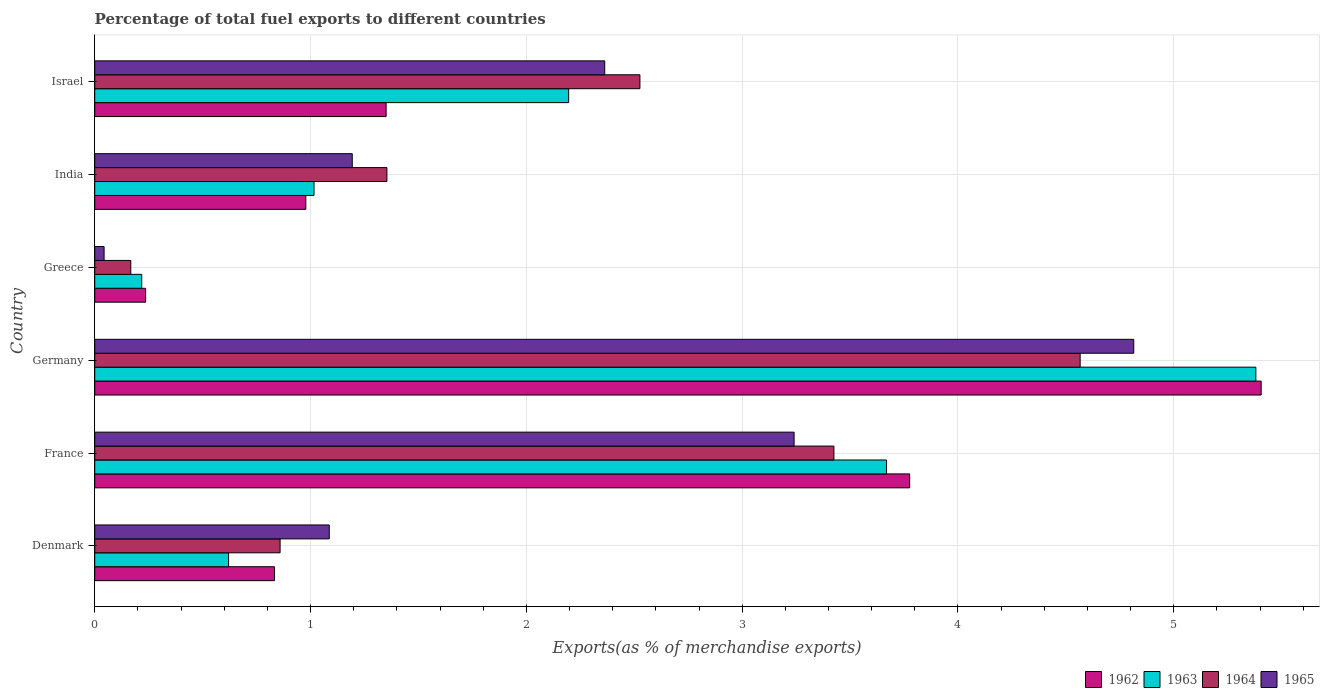How many different coloured bars are there?
Your answer should be very brief. 4. Are the number of bars per tick equal to the number of legend labels?
Offer a terse response. Yes. How many bars are there on the 4th tick from the top?
Your answer should be compact. 4. How many bars are there on the 1st tick from the bottom?
Offer a terse response. 4. What is the label of the 1st group of bars from the top?
Offer a terse response. Israel. What is the percentage of exports to different countries in 1962 in Israel?
Your answer should be compact. 1.35. Across all countries, what is the maximum percentage of exports to different countries in 1965?
Offer a very short reply. 4.81. Across all countries, what is the minimum percentage of exports to different countries in 1964?
Offer a very short reply. 0.17. What is the total percentage of exports to different countries in 1962 in the graph?
Your answer should be compact. 12.58. What is the difference between the percentage of exports to different countries in 1964 in India and that in Israel?
Keep it short and to the point. -1.17. What is the difference between the percentage of exports to different countries in 1963 in Greece and the percentage of exports to different countries in 1965 in Israel?
Give a very brief answer. -2.15. What is the average percentage of exports to different countries in 1963 per country?
Provide a short and direct response. 2.18. What is the difference between the percentage of exports to different countries in 1965 and percentage of exports to different countries in 1962 in Greece?
Ensure brevity in your answer.  -0.19. What is the ratio of the percentage of exports to different countries in 1962 in Denmark to that in France?
Give a very brief answer. 0.22. Is the percentage of exports to different countries in 1963 in France less than that in Israel?
Keep it short and to the point. No. Is the difference between the percentage of exports to different countries in 1965 in Denmark and India greater than the difference between the percentage of exports to different countries in 1962 in Denmark and India?
Your response must be concise. Yes. What is the difference between the highest and the second highest percentage of exports to different countries in 1964?
Your response must be concise. 1.14. What is the difference between the highest and the lowest percentage of exports to different countries in 1964?
Provide a succinct answer. 4.4. Is the sum of the percentage of exports to different countries in 1965 in Denmark and Germany greater than the maximum percentage of exports to different countries in 1963 across all countries?
Your answer should be very brief. Yes. What does the 3rd bar from the bottom in Israel represents?
Offer a terse response. 1964. Are all the bars in the graph horizontal?
Offer a terse response. Yes. How many countries are there in the graph?
Your answer should be compact. 6. Does the graph contain grids?
Ensure brevity in your answer.  Yes. How many legend labels are there?
Offer a terse response. 4. What is the title of the graph?
Keep it short and to the point. Percentage of total fuel exports to different countries. Does "2003" appear as one of the legend labels in the graph?
Offer a very short reply. No. What is the label or title of the X-axis?
Offer a terse response. Exports(as % of merchandise exports). What is the Exports(as % of merchandise exports) in 1962 in Denmark?
Provide a succinct answer. 0.83. What is the Exports(as % of merchandise exports) of 1963 in Denmark?
Offer a very short reply. 0.62. What is the Exports(as % of merchandise exports) in 1964 in Denmark?
Keep it short and to the point. 0.86. What is the Exports(as % of merchandise exports) of 1965 in Denmark?
Make the answer very short. 1.09. What is the Exports(as % of merchandise exports) of 1962 in France?
Provide a succinct answer. 3.78. What is the Exports(as % of merchandise exports) in 1963 in France?
Give a very brief answer. 3.67. What is the Exports(as % of merchandise exports) in 1964 in France?
Your response must be concise. 3.43. What is the Exports(as % of merchandise exports) in 1965 in France?
Your answer should be very brief. 3.24. What is the Exports(as % of merchandise exports) of 1962 in Germany?
Give a very brief answer. 5.4. What is the Exports(as % of merchandise exports) in 1963 in Germany?
Your answer should be compact. 5.38. What is the Exports(as % of merchandise exports) of 1964 in Germany?
Keep it short and to the point. 4.57. What is the Exports(as % of merchandise exports) in 1965 in Germany?
Provide a short and direct response. 4.81. What is the Exports(as % of merchandise exports) of 1962 in Greece?
Provide a short and direct response. 0.24. What is the Exports(as % of merchandise exports) in 1963 in Greece?
Your response must be concise. 0.22. What is the Exports(as % of merchandise exports) of 1964 in Greece?
Your response must be concise. 0.17. What is the Exports(as % of merchandise exports) of 1965 in Greece?
Your response must be concise. 0.04. What is the Exports(as % of merchandise exports) in 1962 in India?
Make the answer very short. 0.98. What is the Exports(as % of merchandise exports) in 1963 in India?
Give a very brief answer. 1.02. What is the Exports(as % of merchandise exports) of 1964 in India?
Ensure brevity in your answer.  1.35. What is the Exports(as % of merchandise exports) in 1965 in India?
Offer a very short reply. 1.19. What is the Exports(as % of merchandise exports) of 1962 in Israel?
Your answer should be compact. 1.35. What is the Exports(as % of merchandise exports) in 1963 in Israel?
Provide a succinct answer. 2.2. What is the Exports(as % of merchandise exports) of 1964 in Israel?
Your answer should be compact. 2.53. What is the Exports(as % of merchandise exports) of 1965 in Israel?
Make the answer very short. 2.36. Across all countries, what is the maximum Exports(as % of merchandise exports) in 1962?
Offer a terse response. 5.4. Across all countries, what is the maximum Exports(as % of merchandise exports) in 1963?
Your answer should be very brief. 5.38. Across all countries, what is the maximum Exports(as % of merchandise exports) of 1964?
Provide a short and direct response. 4.57. Across all countries, what is the maximum Exports(as % of merchandise exports) of 1965?
Offer a terse response. 4.81. Across all countries, what is the minimum Exports(as % of merchandise exports) of 1962?
Your answer should be compact. 0.24. Across all countries, what is the minimum Exports(as % of merchandise exports) of 1963?
Provide a succinct answer. 0.22. Across all countries, what is the minimum Exports(as % of merchandise exports) in 1964?
Give a very brief answer. 0.17. Across all countries, what is the minimum Exports(as % of merchandise exports) of 1965?
Provide a short and direct response. 0.04. What is the total Exports(as % of merchandise exports) of 1962 in the graph?
Provide a short and direct response. 12.58. What is the total Exports(as % of merchandise exports) in 1963 in the graph?
Ensure brevity in your answer.  13.1. What is the total Exports(as % of merchandise exports) in 1964 in the graph?
Offer a very short reply. 12.9. What is the total Exports(as % of merchandise exports) of 1965 in the graph?
Provide a succinct answer. 12.74. What is the difference between the Exports(as % of merchandise exports) in 1962 in Denmark and that in France?
Ensure brevity in your answer.  -2.94. What is the difference between the Exports(as % of merchandise exports) in 1963 in Denmark and that in France?
Ensure brevity in your answer.  -3.05. What is the difference between the Exports(as % of merchandise exports) of 1964 in Denmark and that in France?
Your answer should be very brief. -2.57. What is the difference between the Exports(as % of merchandise exports) of 1965 in Denmark and that in France?
Keep it short and to the point. -2.15. What is the difference between the Exports(as % of merchandise exports) of 1962 in Denmark and that in Germany?
Make the answer very short. -4.57. What is the difference between the Exports(as % of merchandise exports) in 1963 in Denmark and that in Germany?
Ensure brevity in your answer.  -4.76. What is the difference between the Exports(as % of merchandise exports) of 1964 in Denmark and that in Germany?
Keep it short and to the point. -3.71. What is the difference between the Exports(as % of merchandise exports) in 1965 in Denmark and that in Germany?
Make the answer very short. -3.73. What is the difference between the Exports(as % of merchandise exports) of 1962 in Denmark and that in Greece?
Ensure brevity in your answer.  0.6. What is the difference between the Exports(as % of merchandise exports) of 1963 in Denmark and that in Greece?
Provide a succinct answer. 0.4. What is the difference between the Exports(as % of merchandise exports) of 1964 in Denmark and that in Greece?
Your response must be concise. 0.69. What is the difference between the Exports(as % of merchandise exports) of 1965 in Denmark and that in Greece?
Make the answer very short. 1.04. What is the difference between the Exports(as % of merchandise exports) of 1962 in Denmark and that in India?
Offer a very short reply. -0.14. What is the difference between the Exports(as % of merchandise exports) in 1963 in Denmark and that in India?
Offer a terse response. -0.4. What is the difference between the Exports(as % of merchandise exports) in 1964 in Denmark and that in India?
Make the answer very short. -0.49. What is the difference between the Exports(as % of merchandise exports) of 1965 in Denmark and that in India?
Provide a short and direct response. -0.11. What is the difference between the Exports(as % of merchandise exports) in 1962 in Denmark and that in Israel?
Your answer should be compact. -0.52. What is the difference between the Exports(as % of merchandise exports) of 1963 in Denmark and that in Israel?
Offer a very short reply. -1.58. What is the difference between the Exports(as % of merchandise exports) of 1964 in Denmark and that in Israel?
Offer a very short reply. -1.67. What is the difference between the Exports(as % of merchandise exports) in 1965 in Denmark and that in Israel?
Offer a very short reply. -1.28. What is the difference between the Exports(as % of merchandise exports) of 1962 in France and that in Germany?
Your answer should be compact. -1.63. What is the difference between the Exports(as % of merchandise exports) in 1963 in France and that in Germany?
Provide a short and direct response. -1.71. What is the difference between the Exports(as % of merchandise exports) of 1964 in France and that in Germany?
Your answer should be very brief. -1.14. What is the difference between the Exports(as % of merchandise exports) in 1965 in France and that in Germany?
Your answer should be very brief. -1.57. What is the difference between the Exports(as % of merchandise exports) of 1962 in France and that in Greece?
Ensure brevity in your answer.  3.54. What is the difference between the Exports(as % of merchandise exports) in 1963 in France and that in Greece?
Keep it short and to the point. 3.45. What is the difference between the Exports(as % of merchandise exports) of 1964 in France and that in Greece?
Ensure brevity in your answer.  3.26. What is the difference between the Exports(as % of merchandise exports) of 1965 in France and that in Greece?
Your answer should be compact. 3.2. What is the difference between the Exports(as % of merchandise exports) in 1962 in France and that in India?
Offer a very short reply. 2.8. What is the difference between the Exports(as % of merchandise exports) of 1963 in France and that in India?
Provide a succinct answer. 2.65. What is the difference between the Exports(as % of merchandise exports) in 1964 in France and that in India?
Your answer should be very brief. 2.07. What is the difference between the Exports(as % of merchandise exports) in 1965 in France and that in India?
Offer a very short reply. 2.05. What is the difference between the Exports(as % of merchandise exports) of 1962 in France and that in Israel?
Provide a short and direct response. 2.43. What is the difference between the Exports(as % of merchandise exports) of 1963 in France and that in Israel?
Your answer should be compact. 1.47. What is the difference between the Exports(as % of merchandise exports) of 1964 in France and that in Israel?
Provide a succinct answer. 0.9. What is the difference between the Exports(as % of merchandise exports) in 1965 in France and that in Israel?
Ensure brevity in your answer.  0.88. What is the difference between the Exports(as % of merchandise exports) of 1962 in Germany and that in Greece?
Provide a succinct answer. 5.17. What is the difference between the Exports(as % of merchandise exports) of 1963 in Germany and that in Greece?
Provide a succinct answer. 5.16. What is the difference between the Exports(as % of merchandise exports) of 1964 in Germany and that in Greece?
Your response must be concise. 4.4. What is the difference between the Exports(as % of merchandise exports) of 1965 in Germany and that in Greece?
Offer a very short reply. 4.77. What is the difference between the Exports(as % of merchandise exports) of 1962 in Germany and that in India?
Ensure brevity in your answer.  4.43. What is the difference between the Exports(as % of merchandise exports) of 1963 in Germany and that in India?
Provide a succinct answer. 4.36. What is the difference between the Exports(as % of merchandise exports) in 1964 in Germany and that in India?
Offer a very short reply. 3.21. What is the difference between the Exports(as % of merchandise exports) of 1965 in Germany and that in India?
Your answer should be compact. 3.62. What is the difference between the Exports(as % of merchandise exports) in 1962 in Germany and that in Israel?
Provide a short and direct response. 4.05. What is the difference between the Exports(as % of merchandise exports) of 1963 in Germany and that in Israel?
Your answer should be very brief. 3.18. What is the difference between the Exports(as % of merchandise exports) in 1964 in Germany and that in Israel?
Offer a terse response. 2.04. What is the difference between the Exports(as % of merchandise exports) in 1965 in Germany and that in Israel?
Make the answer very short. 2.45. What is the difference between the Exports(as % of merchandise exports) in 1962 in Greece and that in India?
Offer a very short reply. -0.74. What is the difference between the Exports(as % of merchandise exports) in 1963 in Greece and that in India?
Ensure brevity in your answer.  -0.8. What is the difference between the Exports(as % of merchandise exports) in 1964 in Greece and that in India?
Offer a terse response. -1.19. What is the difference between the Exports(as % of merchandise exports) in 1965 in Greece and that in India?
Provide a succinct answer. -1.15. What is the difference between the Exports(as % of merchandise exports) of 1962 in Greece and that in Israel?
Give a very brief answer. -1.11. What is the difference between the Exports(as % of merchandise exports) of 1963 in Greece and that in Israel?
Your answer should be very brief. -1.98. What is the difference between the Exports(as % of merchandise exports) of 1964 in Greece and that in Israel?
Ensure brevity in your answer.  -2.36. What is the difference between the Exports(as % of merchandise exports) in 1965 in Greece and that in Israel?
Keep it short and to the point. -2.32. What is the difference between the Exports(as % of merchandise exports) of 1962 in India and that in Israel?
Your answer should be compact. -0.37. What is the difference between the Exports(as % of merchandise exports) in 1963 in India and that in Israel?
Your answer should be very brief. -1.18. What is the difference between the Exports(as % of merchandise exports) in 1964 in India and that in Israel?
Provide a short and direct response. -1.17. What is the difference between the Exports(as % of merchandise exports) in 1965 in India and that in Israel?
Offer a very short reply. -1.17. What is the difference between the Exports(as % of merchandise exports) of 1962 in Denmark and the Exports(as % of merchandise exports) of 1963 in France?
Your response must be concise. -2.84. What is the difference between the Exports(as % of merchandise exports) in 1962 in Denmark and the Exports(as % of merchandise exports) in 1964 in France?
Offer a terse response. -2.59. What is the difference between the Exports(as % of merchandise exports) in 1962 in Denmark and the Exports(as % of merchandise exports) in 1965 in France?
Offer a terse response. -2.41. What is the difference between the Exports(as % of merchandise exports) in 1963 in Denmark and the Exports(as % of merchandise exports) in 1964 in France?
Your answer should be very brief. -2.8. What is the difference between the Exports(as % of merchandise exports) in 1963 in Denmark and the Exports(as % of merchandise exports) in 1965 in France?
Provide a succinct answer. -2.62. What is the difference between the Exports(as % of merchandise exports) of 1964 in Denmark and the Exports(as % of merchandise exports) of 1965 in France?
Provide a short and direct response. -2.38. What is the difference between the Exports(as % of merchandise exports) in 1962 in Denmark and the Exports(as % of merchandise exports) in 1963 in Germany?
Your answer should be very brief. -4.55. What is the difference between the Exports(as % of merchandise exports) of 1962 in Denmark and the Exports(as % of merchandise exports) of 1964 in Germany?
Offer a terse response. -3.73. What is the difference between the Exports(as % of merchandise exports) of 1962 in Denmark and the Exports(as % of merchandise exports) of 1965 in Germany?
Your response must be concise. -3.98. What is the difference between the Exports(as % of merchandise exports) in 1963 in Denmark and the Exports(as % of merchandise exports) in 1964 in Germany?
Provide a short and direct response. -3.95. What is the difference between the Exports(as % of merchandise exports) of 1963 in Denmark and the Exports(as % of merchandise exports) of 1965 in Germany?
Make the answer very short. -4.19. What is the difference between the Exports(as % of merchandise exports) in 1964 in Denmark and the Exports(as % of merchandise exports) in 1965 in Germany?
Provide a short and direct response. -3.96. What is the difference between the Exports(as % of merchandise exports) of 1962 in Denmark and the Exports(as % of merchandise exports) of 1963 in Greece?
Your answer should be compact. 0.62. What is the difference between the Exports(as % of merchandise exports) in 1962 in Denmark and the Exports(as % of merchandise exports) in 1964 in Greece?
Keep it short and to the point. 0.67. What is the difference between the Exports(as % of merchandise exports) of 1962 in Denmark and the Exports(as % of merchandise exports) of 1965 in Greece?
Ensure brevity in your answer.  0.79. What is the difference between the Exports(as % of merchandise exports) in 1963 in Denmark and the Exports(as % of merchandise exports) in 1964 in Greece?
Provide a short and direct response. 0.45. What is the difference between the Exports(as % of merchandise exports) of 1963 in Denmark and the Exports(as % of merchandise exports) of 1965 in Greece?
Your response must be concise. 0.58. What is the difference between the Exports(as % of merchandise exports) of 1964 in Denmark and the Exports(as % of merchandise exports) of 1965 in Greece?
Offer a very short reply. 0.82. What is the difference between the Exports(as % of merchandise exports) of 1962 in Denmark and the Exports(as % of merchandise exports) of 1963 in India?
Make the answer very short. -0.18. What is the difference between the Exports(as % of merchandise exports) of 1962 in Denmark and the Exports(as % of merchandise exports) of 1964 in India?
Your answer should be compact. -0.52. What is the difference between the Exports(as % of merchandise exports) of 1962 in Denmark and the Exports(as % of merchandise exports) of 1965 in India?
Provide a succinct answer. -0.36. What is the difference between the Exports(as % of merchandise exports) of 1963 in Denmark and the Exports(as % of merchandise exports) of 1964 in India?
Your response must be concise. -0.73. What is the difference between the Exports(as % of merchandise exports) of 1963 in Denmark and the Exports(as % of merchandise exports) of 1965 in India?
Your answer should be very brief. -0.57. What is the difference between the Exports(as % of merchandise exports) in 1964 in Denmark and the Exports(as % of merchandise exports) in 1965 in India?
Make the answer very short. -0.33. What is the difference between the Exports(as % of merchandise exports) of 1962 in Denmark and the Exports(as % of merchandise exports) of 1963 in Israel?
Provide a short and direct response. -1.36. What is the difference between the Exports(as % of merchandise exports) in 1962 in Denmark and the Exports(as % of merchandise exports) in 1964 in Israel?
Offer a very short reply. -1.69. What is the difference between the Exports(as % of merchandise exports) of 1962 in Denmark and the Exports(as % of merchandise exports) of 1965 in Israel?
Your answer should be compact. -1.53. What is the difference between the Exports(as % of merchandise exports) in 1963 in Denmark and the Exports(as % of merchandise exports) in 1964 in Israel?
Provide a short and direct response. -1.91. What is the difference between the Exports(as % of merchandise exports) in 1963 in Denmark and the Exports(as % of merchandise exports) in 1965 in Israel?
Your response must be concise. -1.74. What is the difference between the Exports(as % of merchandise exports) of 1964 in Denmark and the Exports(as % of merchandise exports) of 1965 in Israel?
Keep it short and to the point. -1.5. What is the difference between the Exports(as % of merchandise exports) in 1962 in France and the Exports(as % of merchandise exports) in 1963 in Germany?
Your response must be concise. -1.6. What is the difference between the Exports(as % of merchandise exports) in 1962 in France and the Exports(as % of merchandise exports) in 1964 in Germany?
Your response must be concise. -0.79. What is the difference between the Exports(as % of merchandise exports) in 1962 in France and the Exports(as % of merchandise exports) in 1965 in Germany?
Offer a terse response. -1.04. What is the difference between the Exports(as % of merchandise exports) of 1963 in France and the Exports(as % of merchandise exports) of 1964 in Germany?
Offer a terse response. -0.9. What is the difference between the Exports(as % of merchandise exports) of 1963 in France and the Exports(as % of merchandise exports) of 1965 in Germany?
Make the answer very short. -1.15. What is the difference between the Exports(as % of merchandise exports) of 1964 in France and the Exports(as % of merchandise exports) of 1965 in Germany?
Provide a succinct answer. -1.39. What is the difference between the Exports(as % of merchandise exports) of 1962 in France and the Exports(as % of merchandise exports) of 1963 in Greece?
Your answer should be very brief. 3.56. What is the difference between the Exports(as % of merchandise exports) of 1962 in France and the Exports(as % of merchandise exports) of 1964 in Greece?
Make the answer very short. 3.61. What is the difference between the Exports(as % of merchandise exports) in 1962 in France and the Exports(as % of merchandise exports) in 1965 in Greece?
Your answer should be compact. 3.73. What is the difference between the Exports(as % of merchandise exports) of 1963 in France and the Exports(as % of merchandise exports) of 1964 in Greece?
Your response must be concise. 3.5. What is the difference between the Exports(as % of merchandise exports) in 1963 in France and the Exports(as % of merchandise exports) in 1965 in Greece?
Keep it short and to the point. 3.63. What is the difference between the Exports(as % of merchandise exports) of 1964 in France and the Exports(as % of merchandise exports) of 1965 in Greece?
Offer a very short reply. 3.38. What is the difference between the Exports(as % of merchandise exports) of 1962 in France and the Exports(as % of merchandise exports) of 1963 in India?
Provide a succinct answer. 2.76. What is the difference between the Exports(as % of merchandise exports) of 1962 in France and the Exports(as % of merchandise exports) of 1964 in India?
Offer a terse response. 2.42. What is the difference between the Exports(as % of merchandise exports) in 1962 in France and the Exports(as % of merchandise exports) in 1965 in India?
Ensure brevity in your answer.  2.58. What is the difference between the Exports(as % of merchandise exports) in 1963 in France and the Exports(as % of merchandise exports) in 1964 in India?
Provide a succinct answer. 2.32. What is the difference between the Exports(as % of merchandise exports) in 1963 in France and the Exports(as % of merchandise exports) in 1965 in India?
Your response must be concise. 2.48. What is the difference between the Exports(as % of merchandise exports) in 1964 in France and the Exports(as % of merchandise exports) in 1965 in India?
Give a very brief answer. 2.23. What is the difference between the Exports(as % of merchandise exports) in 1962 in France and the Exports(as % of merchandise exports) in 1963 in Israel?
Provide a succinct answer. 1.58. What is the difference between the Exports(as % of merchandise exports) in 1962 in France and the Exports(as % of merchandise exports) in 1964 in Israel?
Make the answer very short. 1.25. What is the difference between the Exports(as % of merchandise exports) in 1962 in France and the Exports(as % of merchandise exports) in 1965 in Israel?
Provide a succinct answer. 1.41. What is the difference between the Exports(as % of merchandise exports) of 1963 in France and the Exports(as % of merchandise exports) of 1964 in Israel?
Provide a short and direct response. 1.14. What is the difference between the Exports(as % of merchandise exports) of 1963 in France and the Exports(as % of merchandise exports) of 1965 in Israel?
Give a very brief answer. 1.31. What is the difference between the Exports(as % of merchandise exports) in 1964 in France and the Exports(as % of merchandise exports) in 1965 in Israel?
Your response must be concise. 1.06. What is the difference between the Exports(as % of merchandise exports) of 1962 in Germany and the Exports(as % of merchandise exports) of 1963 in Greece?
Keep it short and to the point. 5.19. What is the difference between the Exports(as % of merchandise exports) of 1962 in Germany and the Exports(as % of merchandise exports) of 1964 in Greece?
Ensure brevity in your answer.  5.24. What is the difference between the Exports(as % of merchandise exports) in 1962 in Germany and the Exports(as % of merchandise exports) in 1965 in Greece?
Keep it short and to the point. 5.36. What is the difference between the Exports(as % of merchandise exports) in 1963 in Germany and the Exports(as % of merchandise exports) in 1964 in Greece?
Provide a succinct answer. 5.21. What is the difference between the Exports(as % of merchandise exports) in 1963 in Germany and the Exports(as % of merchandise exports) in 1965 in Greece?
Offer a very short reply. 5.34. What is the difference between the Exports(as % of merchandise exports) of 1964 in Germany and the Exports(as % of merchandise exports) of 1965 in Greece?
Keep it short and to the point. 4.52. What is the difference between the Exports(as % of merchandise exports) in 1962 in Germany and the Exports(as % of merchandise exports) in 1963 in India?
Offer a terse response. 4.39. What is the difference between the Exports(as % of merchandise exports) in 1962 in Germany and the Exports(as % of merchandise exports) in 1964 in India?
Keep it short and to the point. 4.05. What is the difference between the Exports(as % of merchandise exports) of 1962 in Germany and the Exports(as % of merchandise exports) of 1965 in India?
Ensure brevity in your answer.  4.21. What is the difference between the Exports(as % of merchandise exports) of 1963 in Germany and the Exports(as % of merchandise exports) of 1964 in India?
Offer a very short reply. 4.03. What is the difference between the Exports(as % of merchandise exports) in 1963 in Germany and the Exports(as % of merchandise exports) in 1965 in India?
Your response must be concise. 4.19. What is the difference between the Exports(as % of merchandise exports) in 1964 in Germany and the Exports(as % of merchandise exports) in 1965 in India?
Give a very brief answer. 3.37. What is the difference between the Exports(as % of merchandise exports) in 1962 in Germany and the Exports(as % of merchandise exports) in 1963 in Israel?
Offer a very short reply. 3.21. What is the difference between the Exports(as % of merchandise exports) in 1962 in Germany and the Exports(as % of merchandise exports) in 1964 in Israel?
Provide a succinct answer. 2.88. What is the difference between the Exports(as % of merchandise exports) in 1962 in Germany and the Exports(as % of merchandise exports) in 1965 in Israel?
Provide a succinct answer. 3.04. What is the difference between the Exports(as % of merchandise exports) in 1963 in Germany and the Exports(as % of merchandise exports) in 1964 in Israel?
Provide a succinct answer. 2.85. What is the difference between the Exports(as % of merchandise exports) in 1963 in Germany and the Exports(as % of merchandise exports) in 1965 in Israel?
Offer a very short reply. 3.02. What is the difference between the Exports(as % of merchandise exports) in 1964 in Germany and the Exports(as % of merchandise exports) in 1965 in Israel?
Offer a very short reply. 2.2. What is the difference between the Exports(as % of merchandise exports) of 1962 in Greece and the Exports(as % of merchandise exports) of 1963 in India?
Your answer should be very brief. -0.78. What is the difference between the Exports(as % of merchandise exports) of 1962 in Greece and the Exports(as % of merchandise exports) of 1964 in India?
Ensure brevity in your answer.  -1.12. What is the difference between the Exports(as % of merchandise exports) of 1962 in Greece and the Exports(as % of merchandise exports) of 1965 in India?
Keep it short and to the point. -0.96. What is the difference between the Exports(as % of merchandise exports) of 1963 in Greece and the Exports(as % of merchandise exports) of 1964 in India?
Offer a very short reply. -1.14. What is the difference between the Exports(as % of merchandise exports) of 1963 in Greece and the Exports(as % of merchandise exports) of 1965 in India?
Give a very brief answer. -0.98. What is the difference between the Exports(as % of merchandise exports) in 1964 in Greece and the Exports(as % of merchandise exports) in 1965 in India?
Your answer should be very brief. -1.03. What is the difference between the Exports(as % of merchandise exports) of 1962 in Greece and the Exports(as % of merchandise exports) of 1963 in Israel?
Ensure brevity in your answer.  -1.96. What is the difference between the Exports(as % of merchandise exports) in 1962 in Greece and the Exports(as % of merchandise exports) in 1964 in Israel?
Your answer should be very brief. -2.29. What is the difference between the Exports(as % of merchandise exports) in 1962 in Greece and the Exports(as % of merchandise exports) in 1965 in Israel?
Provide a succinct answer. -2.13. What is the difference between the Exports(as % of merchandise exports) of 1963 in Greece and the Exports(as % of merchandise exports) of 1964 in Israel?
Your answer should be very brief. -2.31. What is the difference between the Exports(as % of merchandise exports) in 1963 in Greece and the Exports(as % of merchandise exports) in 1965 in Israel?
Provide a short and direct response. -2.15. What is the difference between the Exports(as % of merchandise exports) of 1964 in Greece and the Exports(as % of merchandise exports) of 1965 in Israel?
Ensure brevity in your answer.  -2.2. What is the difference between the Exports(as % of merchandise exports) of 1962 in India and the Exports(as % of merchandise exports) of 1963 in Israel?
Your answer should be very brief. -1.22. What is the difference between the Exports(as % of merchandise exports) in 1962 in India and the Exports(as % of merchandise exports) in 1964 in Israel?
Make the answer very short. -1.55. What is the difference between the Exports(as % of merchandise exports) of 1962 in India and the Exports(as % of merchandise exports) of 1965 in Israel?
Ensure brevity in your answer.  -1.38. What is the difference between the Exports(as % of merchandise exports) of 1963 in India and the Exports(as % of merchandise exports) of 1964 in Israel?
Your response must be concise. -1.51. What is the difference between the Exports(as % of merchandise exports) in 1963 in India and the Exports(as % of merchandise exports) in 1965 in Israel?
Provide a succinct answer. -1.35. What is the difference between the Exports(as % of merchandise exports) of 1964 in India and the Exports(as % of merchandise exports) of 1965 in Israel?
Your response must be concise. -1.01. What is the average Exports(as % of merchandise exports) of 1962 per country?
Your answer should be very brief. 2.1. What is the average Exports(as % of merchandise exports) of 1963 per country?
Make the answer very short. 2.18. What is the average Exports(as % of merchandise exports) in 1964 per country?
Make the answer very short. 2.15. What is the average Exports(as % of merchandise exports) in 1965 per country?
Your response must be concise. 2.12. What is the difference between the Exports(as % of merchandise exports) of 1962 and Exports(as % of merchandise exports) of 1963 in Denmark?
Your answer should be compact. 0.21. What is the difference between the Exports(as % of merchandise exports) of 1962 and Exports(as % of merchandise exports) of 1964 in Denmark?
Your answer should be very brief. -0.03. What is the difference between the Exports(as % of merchandise exports) in 1962 and Exports(as % of merchandise exports) in 1965 in Denmark?
Your answer should be compact. -0.25. What is the difference between the Exports(as % of merchandise exports) of 1963 and Exports(as % of merchandise exports) of 1964 in Denmark?
Your response must be concise. -0.24. What is the difference between the Exports(as % of merchandise exports) of 1963 and Exports(as % of merchandise exports) of 1965 in Denmark?
Provide a short and direct response. -0.47. What is the difference between the Exports(as % of merchandise exports) in 1964 and Exports(as % of merchandise exports) in 1965 in Denmark?
Keep it short and to the point. -0.23. What is the difference between the Exports(as % of merchandise exports) in 1962 and Exports(as % of merchandise exports) in 1963 in France?
Provide a short and direct response. 0.11. What is the difference between the Exports(as % of merchandise exports) of 1962 and Exports(as % of merchandise exports) of 1964 in France?
Give a very brief answer. 0.35. What is the difference between the Exports(as % of merchandise exports) in 1962 and Exports(as % of merchandise exports) in 1965 in France?
Ensure brevity in your answer.  0.54. What is the difference between the Exports(as % of merchandise exports) of 1963 and Exports(as % of merchandise exports) of 1964 in France?
Provide a short and direct response. 0.24. What is the difference between the Exports(as % of merchandise exports) in 1963 and Exports(as % of merchandise exports) in 1965 in France?
Make the answer very short. 0.43. What is the difference between the Exports(as % of merchandise exports) of 1964 and Exports(as % of merchandise exports) of 1965 in France?
Make the answer very short. 0.18. What is the difference between the Exports(as % of merchandise exports) of 1962 and Exports(as % of merchandise exports) of 1963 in Germany?
Make the answer very short. 0.02. What is the difference between the Exports(as % of merchandise exports) of 1962 and Exports(as % of merchandise exports) of 1964 in Germany?
Provide a short and direct response. 0.84. What is the difference between the Exports(as % of merchandise exports) in 1962 and Exports(as % of merchandise exports) in 1965 in Germany?
Your response must be concise. 0.59. What is the difference between the Exports(as % of merchandise exports) in 1963 and Exports(as % of merchandise exports) in 1964 in Germany?
Keep it short and to the point. 0.81. What is the difference between the Exports(as % of merchandise exports) of 1963 and Exports(as % of merchandise exports) of 1965 in Germany?
Offer a terse response. 0.57. What is the difference between the Exports(as % of merchandise exports) in 1964 and Exports(as % of merchandise exports) in 1965 in Germany?
Your response must be concise. -0.25. What is the difference between the Exports(as % of merchandise exports) in 1962 and Exports(as % of merchandise exports) in 1963 in Greece?
Provide a short and direct response. 0.02. What is the difference between the Exports(as % of merchandise exports) of 1962 and Exports(as % of merchandise exports) of 1964 in Greece?
Your response must be concise. 0.07. What is the difference between the Exports(as % of merchandise exports) of 1962 and Exports(as % of merchandise exports) of 1965 in Greece?
Your response must be concise. 0.19. What is the difference between the Exports(as % of merchandise exports) of 1963 and Exports(as % of merchandise exports) of 1964 in Greece?
Ensure brevity in your answer.  0.05. What is the difference between the Exports(as % of merchandise exports) in 1963 and Exports(as % of merchandise exports) in 1965 in Greece?
Your response must be concise. 0.17. What is the difference between the Exports(as % of merchandise exports) of 1964 and Exports(as % of merchandise exports) of 1965 in Greece?
Your answer should be compact. 0.12. What is the difference between the Exports(as % of merchandise exports) of 1962 and Exports(as % of merchandise exports) of 1963 in India?
Provide a short and direct response. -0.04. What is the difference between the Exports(as % of merchandise exports) in 1962 and Exports(as % of merchandise exports) in 1964 in India?
Ensure brevity in your answer.  -0.38. What is the difference between the Exports(as % of merchandise exports) of 1962 and Exports(as % of merchandise exports) of 1965 in India?
Provide a succinct answer. -0.22. What is the difference between the Exports(as % of merchandise exports) of 1963 and Exports(as % of merchandise exports) of 1964 in India?
Your response must be concise. -0.34. What is the difference between the Exports(as % of merchandise exports) in 1963 and Exports(as % of merchandise exports) in 1965 in India?
Offer a very short reply. -0.18. What is the difference between the Exports(as % of merchandise exports) in 1964 and Exports(as % of merchandise exports) in 1965 in India?
Give a very brief answer. 0.16. What is the difference between the Exports(as % of merchandise exports) of 1962 and Exports(as % of merchandise exports) of 1963 in Israel?
Offer a terse response. -0.85. What is the difference between the Exports(as % of merchandise exports) of 1962 and Exports(as % of merchandise exports) of 1964 in Israel?
Your answer should be very brief. -1.18. What is the difference between the Exports(as % of merchandise exports) of 1962 and Exports(as % of merchandise exports) of 1965 in Israel?
Offer a very short reply. -1.01. What is the difference between the Exports(as % of merchandise exports) in 1963 and Exports(as % of merchandise exports) in 1964 in Israel?
Make the answer very short. -0.33. What is the difference between the Exports(as % of merchandise exports) of 1963 and Exports(as % of merchandise exports) of 1965 in Israel?
Offer a terse response. -0.17. What is the difference between the Exports(as % of merchandise exports) of 1964 and Exports(as % of merchandise exports) of 1965 in Israel?
Ensure brevity in your answer.  0.16. What is the ratio of the Exports(as % of merchandise exports) of 1962 in Denmark to that in France?
Make the answer very short. 0.22. What is the ratio of the Exports(as % of merchandise exports) in 1963 in Denmark to that in France?
Your response must be concise. 0.17. What is the ratio of the Exports(as % of merchandise exports) in 1964 in Denmark to that in France?
Offer a terse response. 0.25. What is the ratio of the Exports(as % of merchandise exports) in 1965 in Denmark to that in France?
Your answer should be compact. 0.34. What is the ratio of the Exports(as % of merchandise exports) of 1962 in Denmark to that in Germany?
Provide a succinct answer. 0.15. What is the ratio of the Exports(as % of merchandise exports) of 1963 in Denmark to that in Germany?
Your answer should be very brief. 0.12. What is the ratio of the Exports(as % of merchandise exports) of 1964 in Denmark to that in Germany?
Provide a succinct answer. 0.19. What is the ratio of the Exports(as % of merchandise exports) in 1965 in Denmark to that in Germany?
Make the answer very short. 0.23. What is the ratio of the Exports(as % of merchandise exports) of 1962 in Denmark to that in Greece?
Provide a short and direct response. 3.53. What is the ratio of the Exports(as % of merchandise exports) of 1963 in Denmark to that in Greece?
Provide a short and direct response. 2.85. What is the ratio of the Exports(as % of merchandise exports) of 1964 in Denmark to that in Greece?
Your answer should be compact. 5.14. What is the ratio of the Exports(as % of merchandise exports) in 1965 in Denmark to that in Greece?
Keep it short and to the point. 25.05. What is the ratio of the Exports(as % of merchandise exports) of 1962 in Denmark to that in India?
Give a very brief answer. 0.85. What is the ratio of the Exports(as % of merchandise exports) of 1963 in Denmark to that in India?
Your answer should be compact. 0.61. What is the ratio of the Exports(as % of merchandise exports) of 1964 in Denmark to that in India?
Your answer should be very brief. 0.63. What is the ratio of the Exports(as % of merchandise exports) in 1965 in Denmark to that in India?
Offer a terse response. 0.91. What is the ratio of the Exports(as % of merchandise exports) of 1962 in Denmark to that in Israel?
Ensure brevity in your answer.  0.62. What is the ratio of the Exports(as % of merchandise exports) of 1963 in Denmark to that in Israel?
Keep it short and to the point. 0.28. What is the ratio of the Exports(as % of merchandise exports) of 1964 in Denmark to that in Israel?
Offer a terse response. 0.34. What is the ratio of the Exports(as % of merchandise exports) of 1965 in Denmark to that in Israel?
Offer a terse response. 0.46. What is the ratio of the Exports(as % of merchandise exports) in 1962 in France to that in Germany?
Provide a short and direct response. 0.7. What is the ratio of the Exports(as % of merchandise exports) of 1963 in France to that in Germany?
Offer a very short reply. 0.68. What is the ratio of the Exports(as % of merchandise exports) in 1964 in France to that in Germany?
Offer a very short reply. 0.75. What is the ratio of the Exports(as % of merchandise exports) of 1965 in France to that in Germany?
Keep it short and to the point. 0.67. What is the ratio of the Exports(as % of merchandise exports) in 1962 in France to that in Greece?
Provide a short and direct response. 16.01. What is the ratio of the Exports(as % of merchandise exports) in 1963 in France to that in Greece?
Your answer should be very brief. 16.85. What is the ratio of the Exports(as % of merchandise exports) of 1964 in France to that in Greece?
Give a very brief answer. 20.5. What is the ratio of the Exports(as % of merchandise exports) of 1965 in France to that in Greece?
Make the answer very short. 74.69. What is the ratio of the Exports(as % of merchandise exports) in 1962 in France to that in India?
Give a very brief answer. 3.86. What is the ratio of the Exports(as % of merchandise exports) in 1963 in France to that in India?
Your response must be concise. 3.61. What is the ratio of the Exports(as % of merchandise exports) of 1964 in France to that in India?
Ensure brevity in your answer.  2.53. What is the ratio of the Exports(as % of merchandise exports) of 1965 in France to that in India?
Make the answer very short. 2.72. What is the ratio of the Exports(as % of merchandise exports) of 1962 in France to that in Israel?
Make the answer very short. 2.8. What is the ratio of the Exports(as % of merchandise exports) of 1963 in France to that in Israel?
Give a very brief answer. 1.67. What is the ratio of the Exports(as % of merchandise exports) of 1964 in France to that in Israel?
Your response must be concise. 1.36. What is the ratio of the Exports(as % of merchandise exports) of 1965 in France to that in Israel?
Ensure brevity in your answer.  1.37. What is the ratio of the Exports(as % of merchandise exports) in 1962 in Germany to that in Greece?
Offer a terse response. 22.91. What is the ratio of the Exports(as % of merchandise exports) in 1963 in Germany to that in Greece?
Ensure brevity in your answer.  24.71. What is the ratio of the Exports(as % of merchandise exports) of 1964 in Germany to that in Greece?
Your response must be concise. 27.34. What is the ratio of the Exports(as % of merchandise exports) in 1965 in Germany to that in Greece?
Give a very brief answer. 110.96. What is the ratio of the Exports(as % of merchandise exports) of 1962 in Germany to that in India?
Provide a succinct answer. 5.53. What is the ratio of the Exports(as % of merchandise exports) in 1963 in Germany to that in India?
Your response must be concise. 5.3. What is the ratio of the Exports(as % of merchandise exports) of 1964 in Germany to that in India?
Offer a terse response. 3.37. What is the ratio of the Exports(as % of merchandise exports) of 1965 in Germany to that in India?
Your answer should be compact. 4.03. What is the ratio of the Exports(as % of merchandise exports) of 1962 in Germany to that in Israel?
Keep it short and to the point. 4. What is the ratio of the Exports(as % of merchandise exports) of 1963 in Germany to that in Israel?
Ensure brevity in your answer.  2.45. What is the ratio of the Exports(as % of merchandise exports) of 1964 in Germany to that in Israel?
Your response must be concise. 1.81. What is the ratio of the Exports(as % of merchandise exports) of 1965 in Germany to that in Israel?
Your answer should be compact. 2.04. What is the ratio of the Exports(as % of merchandise exports) of 1962 in Greece to that in India?
Provide a succinct answer. 0.24. What is the ratio of the Exports(as % of merchandise exports) of 1963 in Greece to that in India?
Your response must be concise. 0.21. What is the ratio of the Exports(as % of merchandise exports) in 1964 in Greece to that in India?
Offer a terse response. 0.12. What is the ratio of the Exports(as % of merchandise exports) in 1965 in Greece to that in India?
Ensure brevity in your answer.  0.04. What is the ratio of the Exports(as % of merchandise exports) in 1962 in Greece to that in Israel?
Provide a succinct answer. 0.17. What is the ratio of the Exports(as % of merchandise exports) in 1963 in Greece to that in Israel?
Your answer should be compact. 0.1. What is the ratio of the Exports(as % of merchandise exports) in 1964 in Greece to that in Israel?
Ensure brevity in your answer.  0.07. What is the ratio of the Exports(as % of merchandise exports) in 1965 in Greece to that in Israel?
Offer a very short reply. 0.02. What is the ratio of the Exports(as % of merchandise exports) in 1962 in India to that in Israel?
Make the answer very short. 0.72. What is the ratio of the Exports(as % of merchandise exports) in 1963 in India to that in Israel?
Ensure brevity in your answer.  0.46. What is the ratio of the Exports(as % of merchandise exports) of 1964 in India to that in Israel?
Offer a terse response. 0.54. What is the ratio of the Exports(as % of merchandise exports) of 1965 in India to that in Israel?
Your response must be concise. 0.51. What is the difference between the highest and the second highest Exports(as % of merchandise exports) of 1962?
Provide a succinct answer. 1.63. What is the difference between the highest and the second highest Exports(as % of merchandise exports) in 1963?
Ensure brevity in your answer.  1.71. What is the difference between the highest and the second highest Exports(as % of merchandise exports) of 1964?
Offer a terse response. 1.14. What is the difference between the highest and the second highest Exports(as % of merchandise exports) in 1965?
Ensure brevity in your answer.  1.57. What is the difference between the highest and the lowest Exports(as % of merchandise exports) in 1962?
Provide a short and direct response. 5.17. What is the difference between the highest and the lowest Exports(as % of merchandise exports) in 1963?
Give a very brief answer. 5.16. What is the difference between the highest and the lowest Exports(as % of merchandise exports) of 1964?
Offer a very short reply. 4.4. What is the difference between the highest and the lowest Exports(as % of merchandise exports) in 1965?
Ensure brevity in your answer.  4.77. 